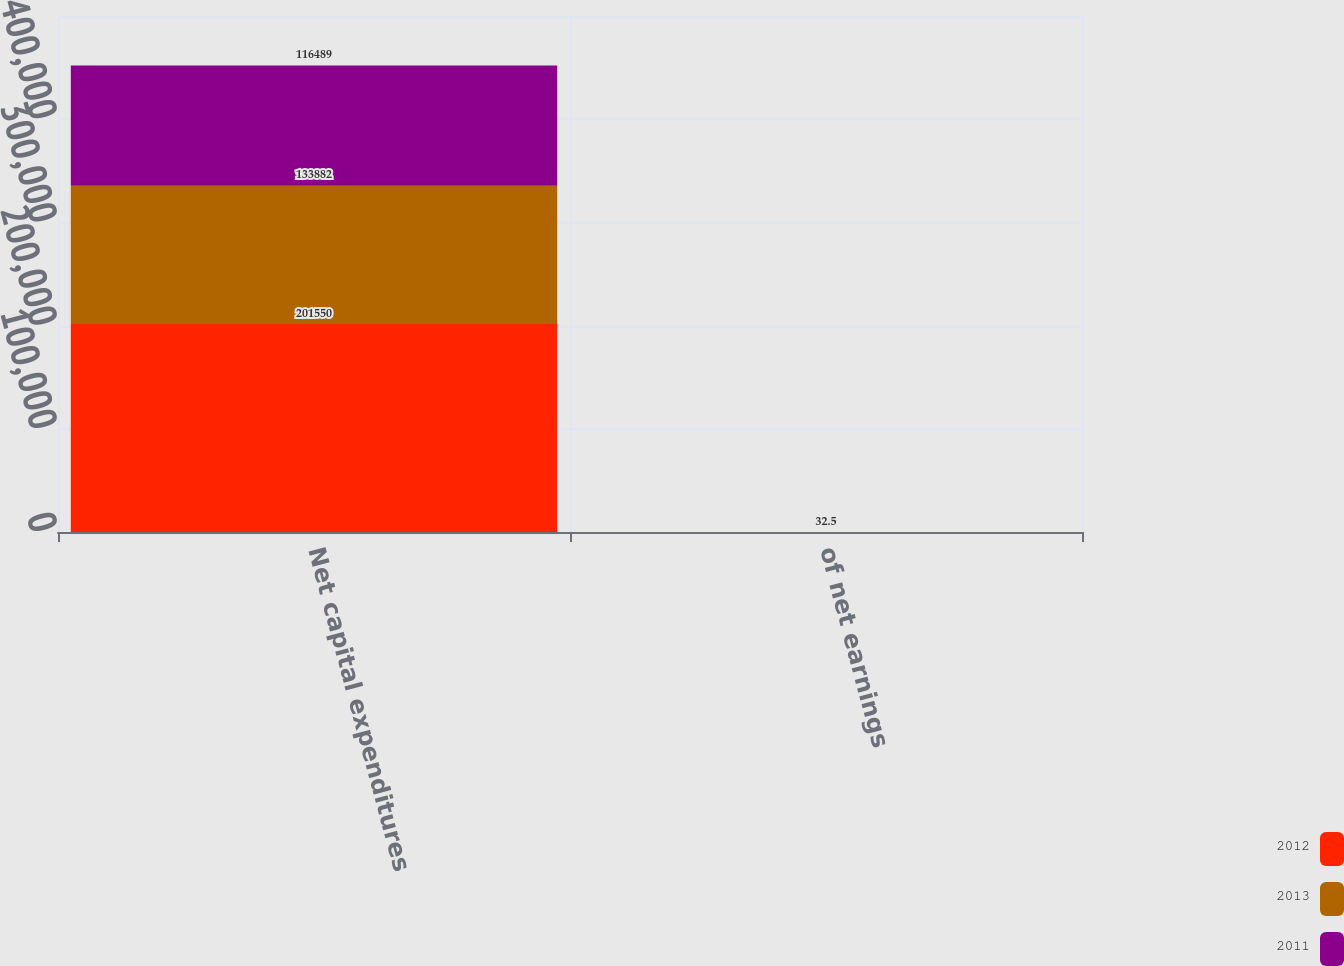<chart> <loc_0><loc_0><loc_500><loc_500><stacked_bar_chart><ecel><fcel>Net capital expenditures<fcel>of net earnings<nl><fcel>2012<fcel>201550<fcel>44.9<nl><fcel>2013<fcel>133882<fcel>31.8<nl><fcel>2011<fcel>116489<fcel>32.5<nl></chart> 